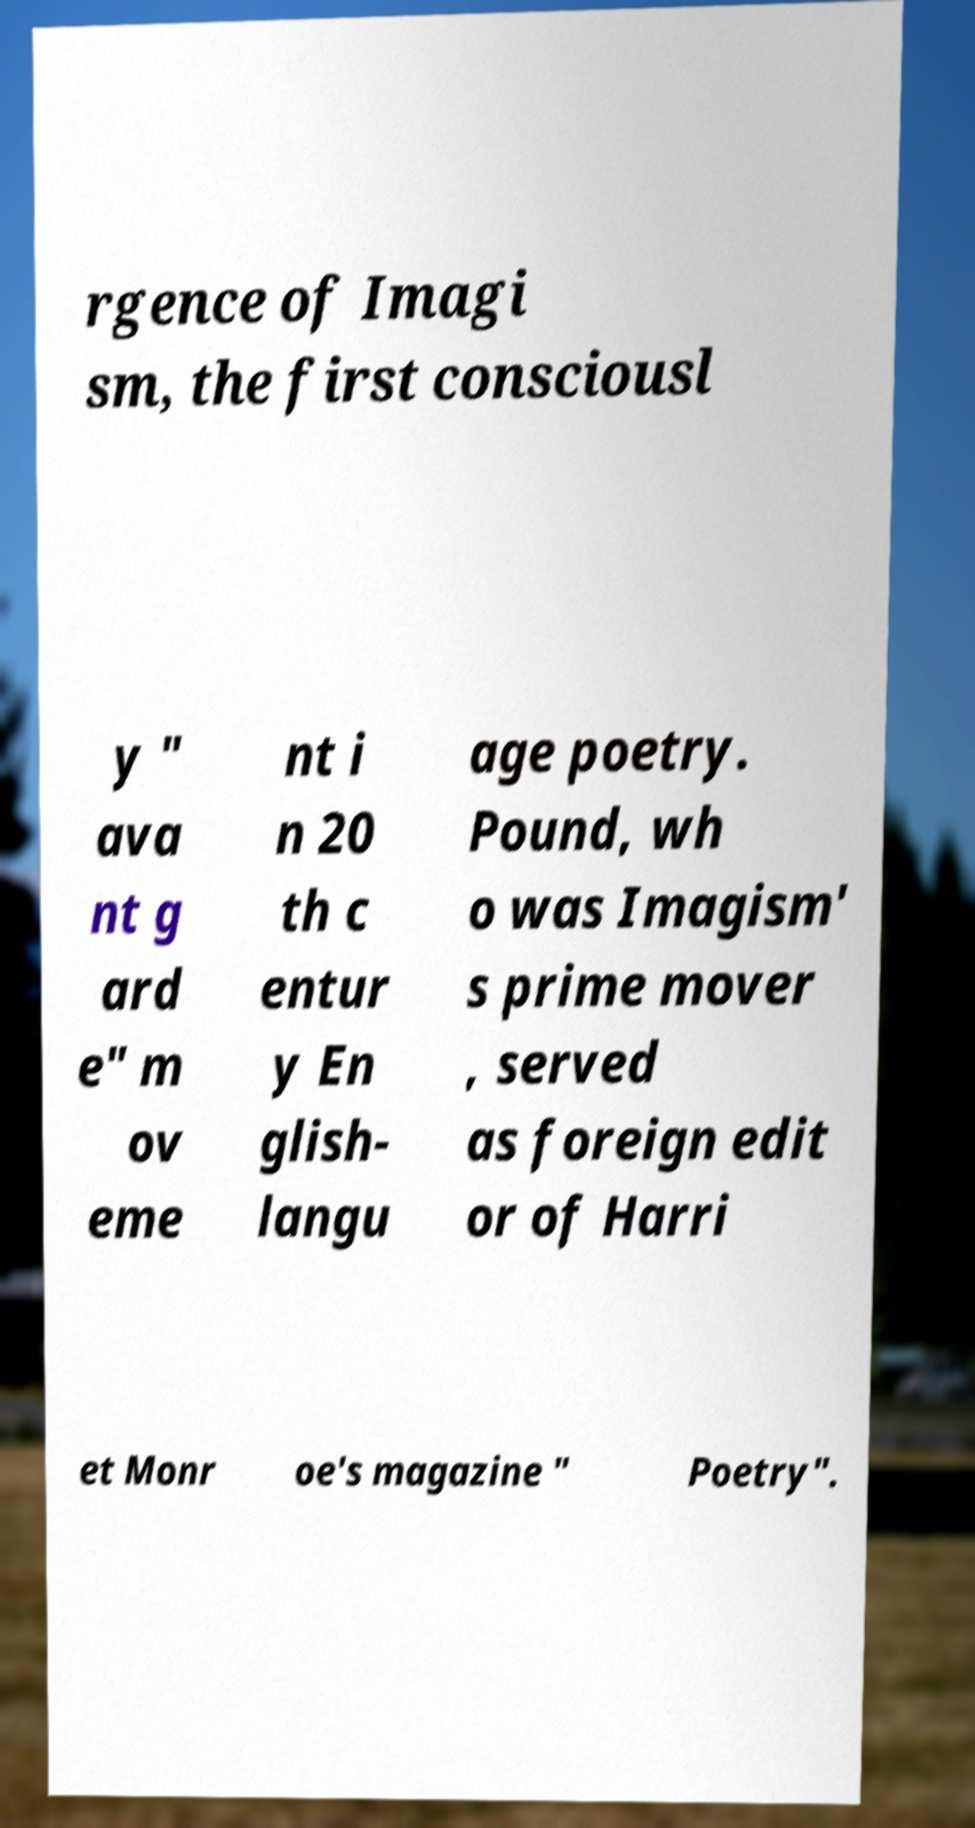Please identify and transcribe the text found in this image. rgence of Imagi sm, the first consciousl y " ava nt g ard e" m ov eme nt i n 20 th c entur y En glish- langu age poetry. Pound, wh o was Imagism' s prime mover , served as foreign edit or of Harri et Monr oe's magazine " Poetry". 